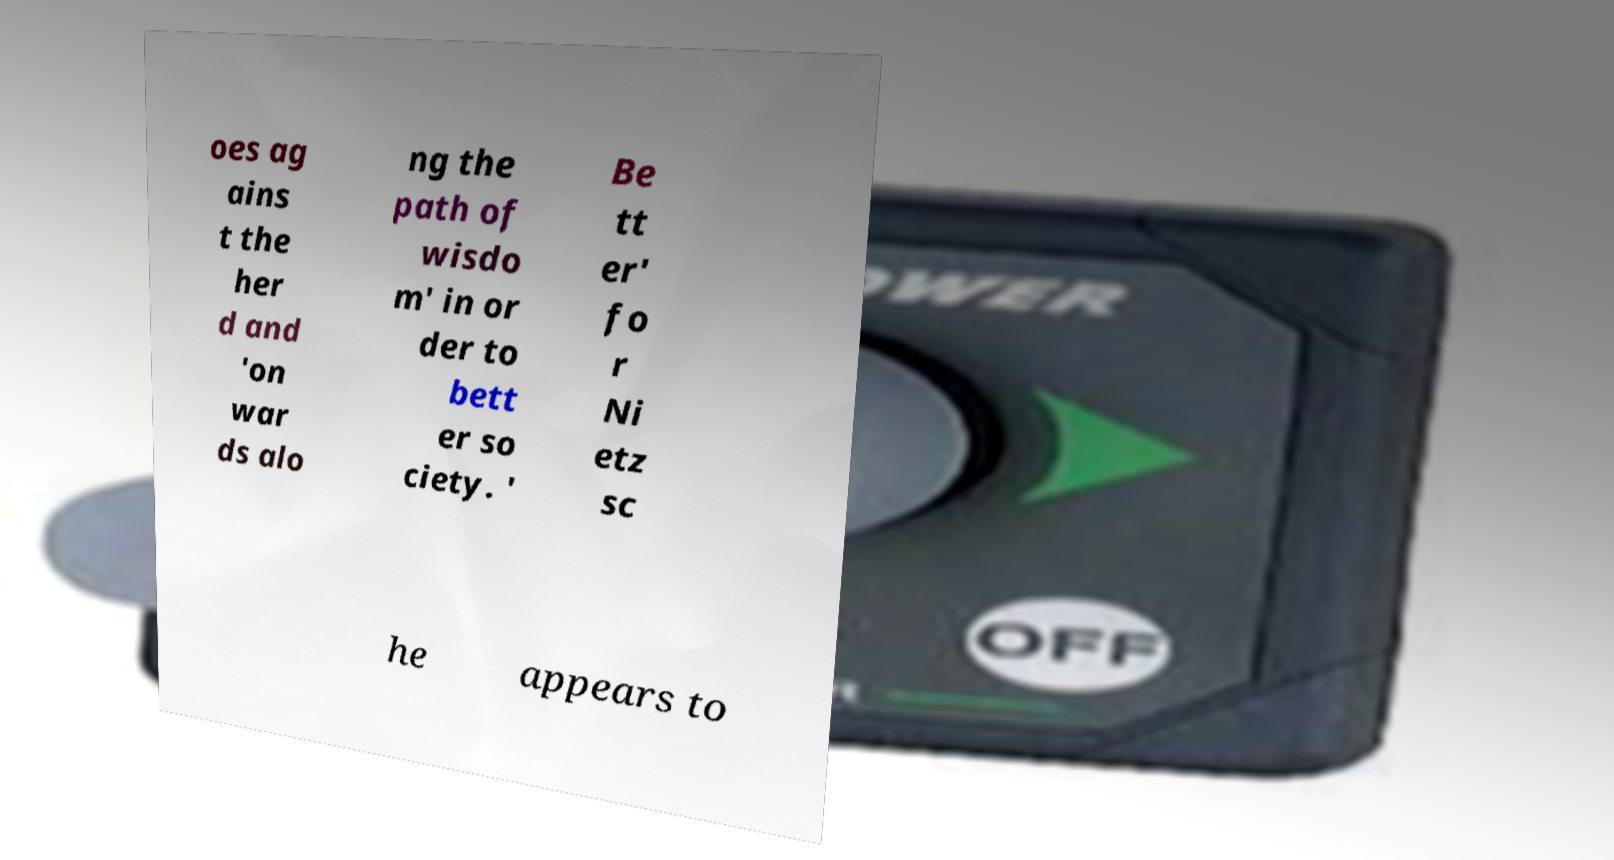Could you extract and type out the text from this image? oes ag ains t the her d and 'on war ds alo ng the path of wisdo m' in or der to bett er so ciety. ' Be tt er' fo r Ni etz sc he appears to 